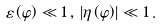<formula> <loc_0><loc_0><loc_500><loc_500>\varepsilon \left ( \varphi \right ) \ll 1 \, , \, \left | \eta \left ( \varphi \right ) \right | \ll 1 \, .</formula> 